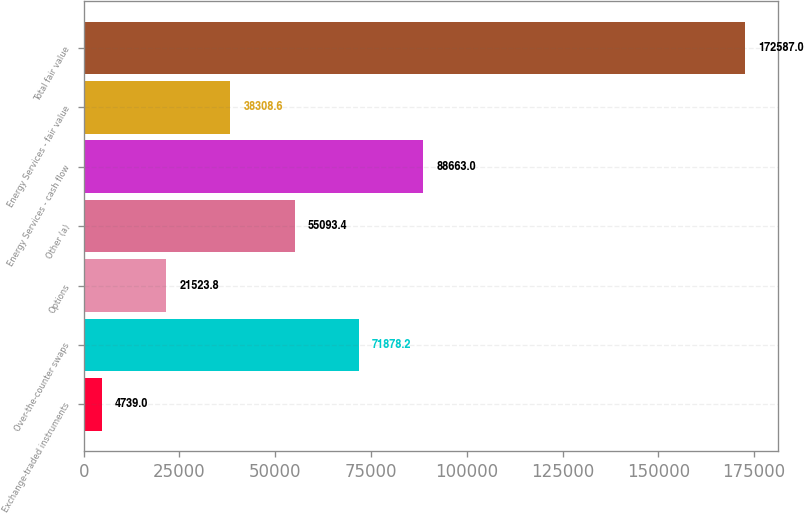Convert chart to OTSL. <chart><loc_0><loc_0><loc_500><loc_500><bar_chart><fcel>Exchange-traded instruments<fcel>Over-the-counter swaps<fcel>Options<fcel>Other (a)<fcel>Energy Services - cash flow<fcel>Energy Services - fair value<fcel>Total fair value<nl><fcel>4739<fcel>71878.2<fcel>21523.8<fcel>55093.4<fcel>88663<fcel>38308.6<fcel>172587<nl></chart> 